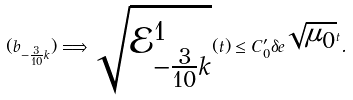Convert formula to latex. <formula><loc_0><loc_0><loc_500><loc_500>( b _ { { - \frac { 3 } { 1 0 } } k } ) \Longrightarrow \sqrt { \mathcal { E } _ { - \frac { 3 } { 1 0 } k } ^ { 1 } } ( t ) \leq C _ { 0 } ^ { \prime } \delta e ^ { \sqrt { \mu _ { 0 } } t } .</formula> 